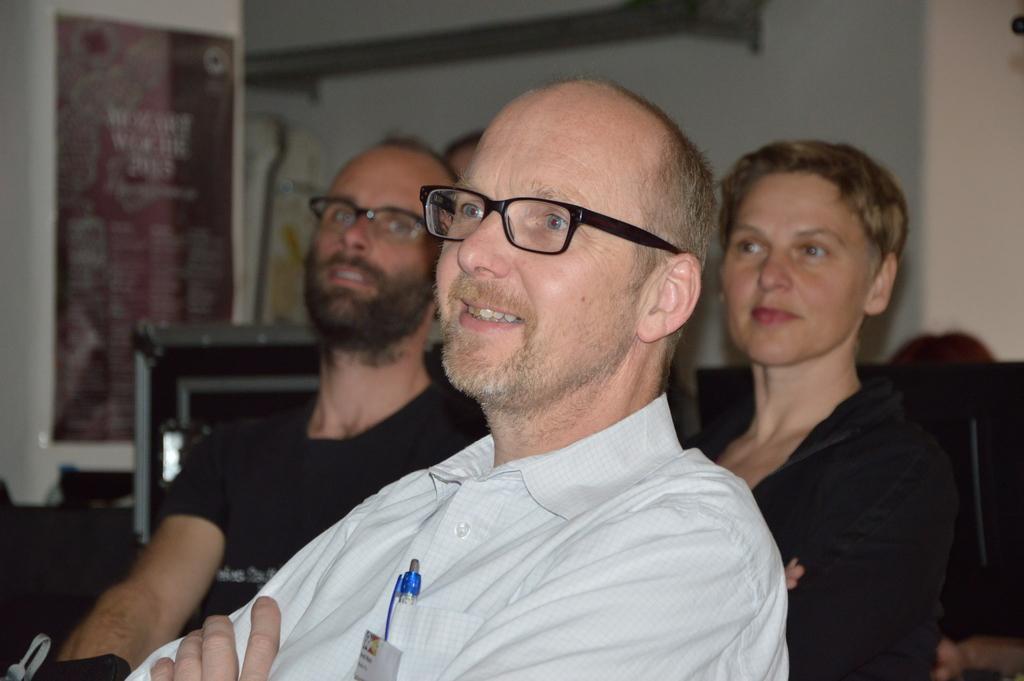Describe this image in one or two sentences. In this image we can see people. In the background of the image there is wall. There is a poster with some text. 